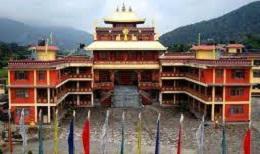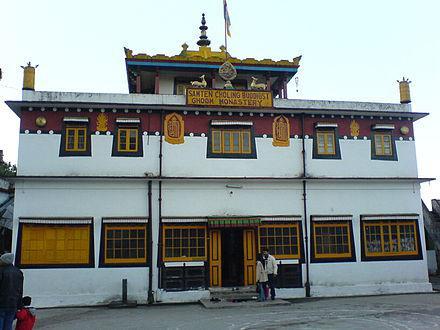The first image is the image on the left, the second image is the image on the right. Evaluate the accuracy of this statement regarding the images: "Both images contain one single building, made of mostly right angles.". Is it true? Answer yes or no. Yes. 